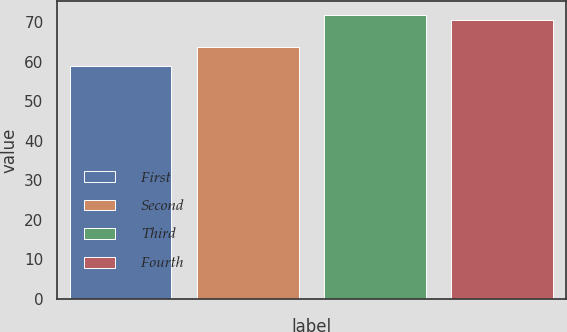Convert chart to OTSL. <chart><loc_0><loc_0><loc_500><loc_500><bar_chart><fcel>First<fcel>Second<fcel>Third<fcel>Fourth<nl><fcel>58.96<fcel>63.69<fcel>71.88<fcel>70.63<nl></chart> 